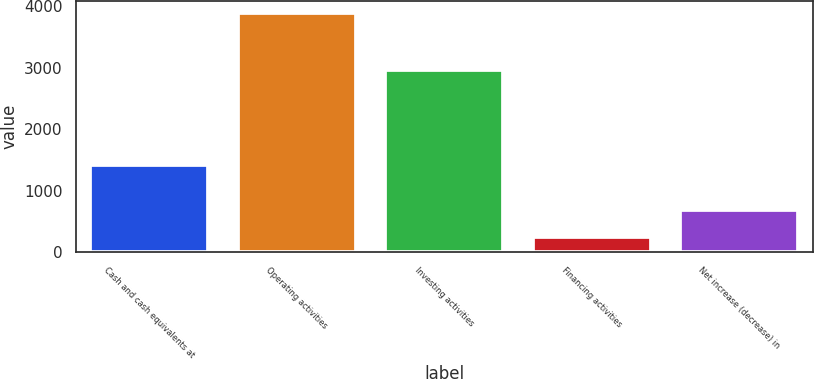<chart> <loc_0><loc_0><loc_500><loc_500><bar_chart><fcel>Cash and cash equivalents at<fcel>Operating activities<fcel>Investing activities<fcel>Financing activities<fcel>Net increase (decrease) in<nl><fcel>1422<fcel>3890<fcel>2955<fcel>252<fcel>683<nl></chart> 